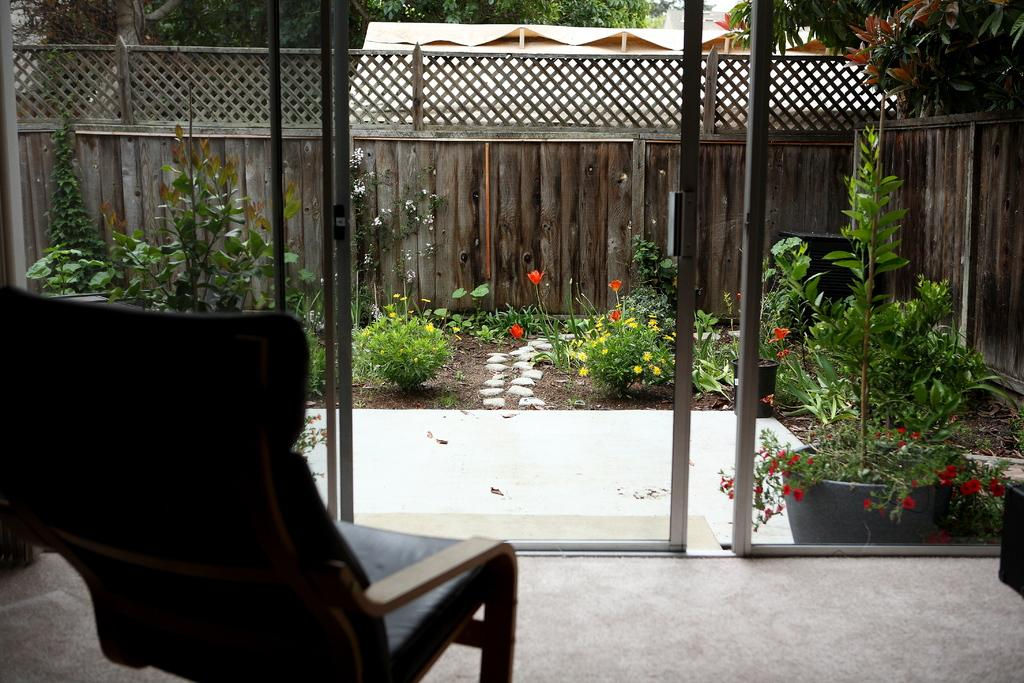What can be seen outside the window in the image? There is a garden outside the window in the image. What is present in the garden? The garden contains plants. What is visible in the background of the garden? There is a boundary in the background of the garden. What is located inside the window? There is a chair inside the window. How much trouble did the plants cause in the garden? There is no mention of trouble or any negative impact caused by the plants in the image. What day is it in the image? The day is not mentioned or depicted in the image. 